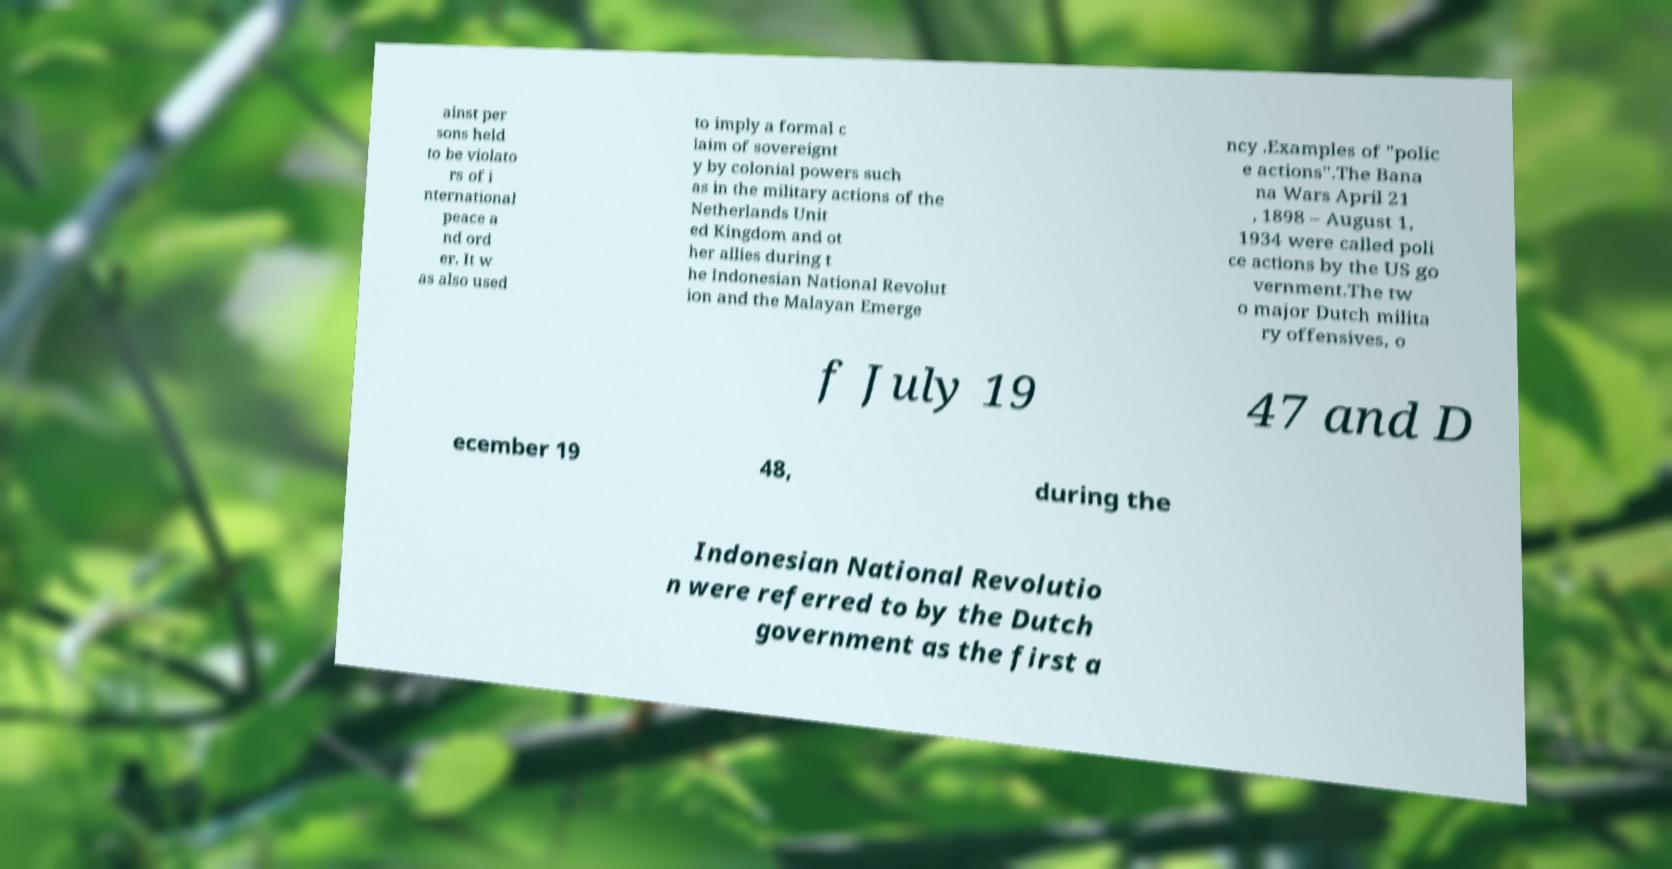Can you accurately transcribe the text from the provided image for me? ainst per sons held to be violato rs of i nternational peace a nd ord er. It w as also used to imply a formal c laim of sovereignt y by colonial powers such as in the military actions of the Netherlands Unit ed Kingdom and ot her allies during t he Indonesian National Revolut ion and the Malayan Emerge ncy .Examples of "polic e actions".The Bana na Wars April 21 , 1898 – August 1, 1934 were called poli ce actions by the US go vernment.The tw o major Dutch milita ry offensives, o f July 19 47 and D ecember 19 48, during the Indonesian National Revolutio n were referred to by the Dutch government as the first a 